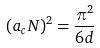<formula> <loc_0><loc_0><loc_500><loc_500>( a _ { c } { N } ) ^ { 2 } = \frac { \pi ^ { 2 } } { 6 d }</formula> 